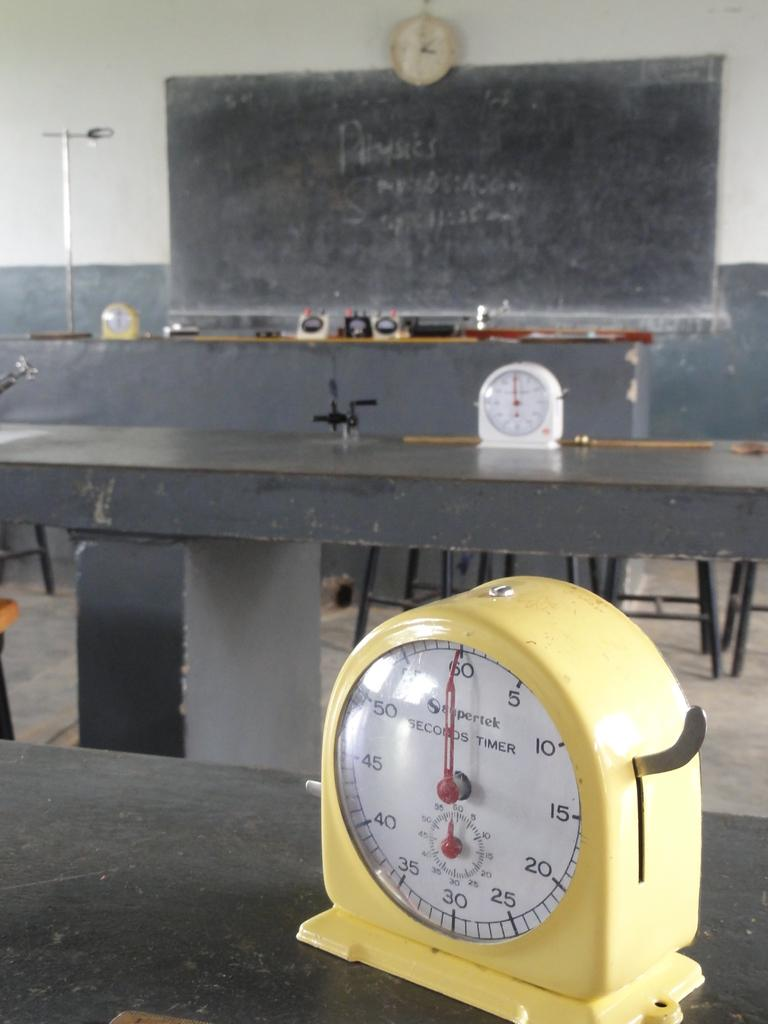Provide a one-sentence caption for the provided image. In a room with a blackboard on one wall sit two SECONDS TIMERs, each with their dials set at the 60/0 mark. 